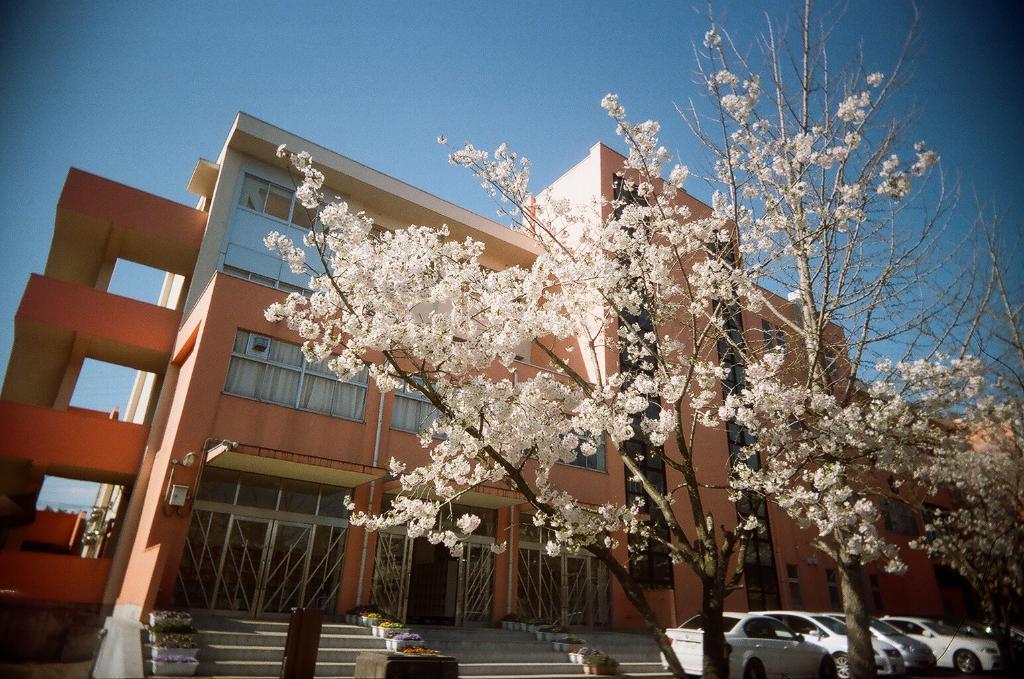Can you describe this image briefly? In this image we can see trees, cars parked here, stairs, building and the blue sky in the background. 